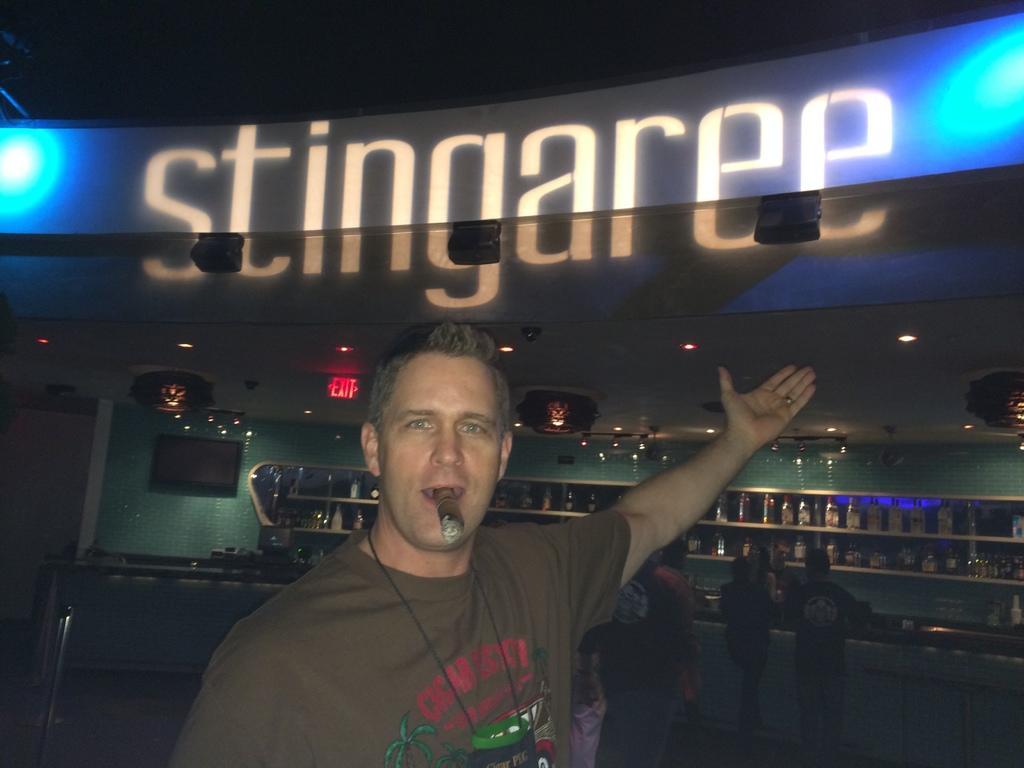In one or two sentences, can you explain what this image depicts? In this image we can see a person smoking, behind him we can see few persons, there are some shelves with bottles, we can see a television on the wall, at the top we can see some lights and an exit board, also we can see some text. 